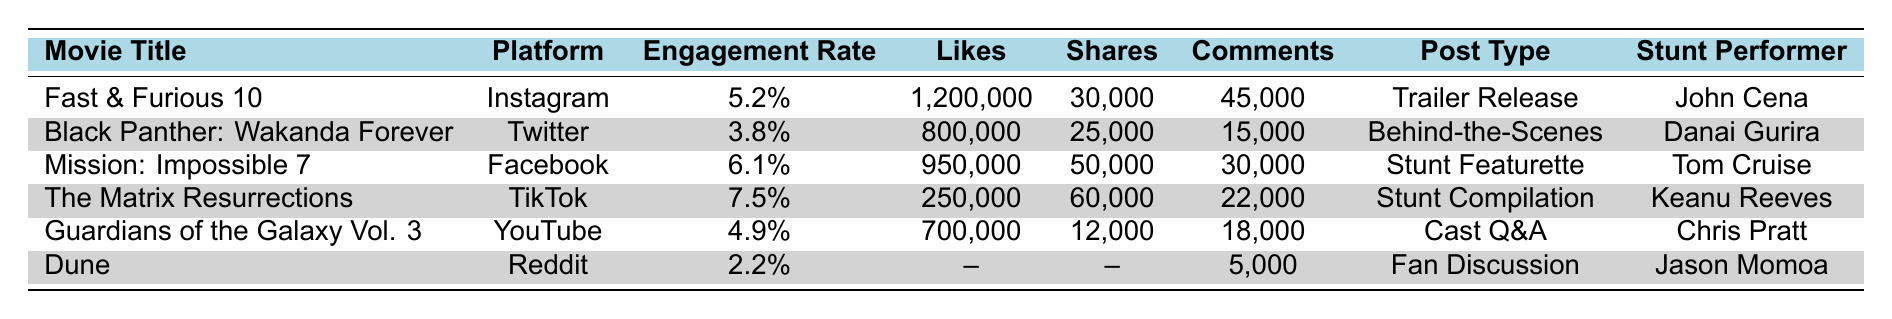What is the engagement rate for "Mission: Impossible 7"? "Mission: Impossible 7" has an engagement rate listed in the table, which shows a value of 6.1%.
Answer: 6.1% Which movie had the highest number of likes? By examining the table, "Fast & Furious 10" has the highest likes with a total of 1,200,000.
Answer: Fast & Furious 10 How many comments did "The Matrix Resurrections" receive? The table indicates that "The Matrix Resurrections" received 22,000 comments.
Answer: 22,000 Is the engagement rate for "Dune" higher than 3%? The engagement rate for "Dune" is 2.2%, which is less than 3%. Therefore, the statement is false.
Answer: No What is the sum of likes for "Guardians of the Galaxy Vol. 3" and "Black Panther: Wakanda Forever"? Adding the likes from both movies: 700,000 (Guardians) + 800,000 (Black Panther) gives 1,500,000 in total.
Answer: 1,500,000 Which platform had the highest engagement rate? By comparing the engagement rates, "The Matrix Resurrections" on TikTok has the highest rate at 7.5%.
Answer: TikTok How many more likes did "Fast & Furious 10" receive than "Dune"? "Fast & Furious 10" has 1,200,000 likes, while "Dune" has no likes (not specified). The difference is 1,200,000.
Answer: 1,200,000 What is the average engagement rate of all the listed movies? The engagement rates are: 5.2%, 3.8%, 6.1%, 7.5%, 4.9%, 2.2% (sum = 29.7%). Dividing by 6 gives 4.95% average engagement rate.
Answer: 4.95% Which stunt performer was featured in the "Cast Q&A" post type? The table states that "Cast Q&A" is associated with Chris Pratt, indicated as the stunt performer.
Answer: Chris Pratt Has "Black Panther: Wakanda Forever" been promoted on Instagram? The table shows that "Black Panther: Wakanda Forever" was promoted on Twitter, not Instagram. Therefore, the statement is false.
Answer: No 